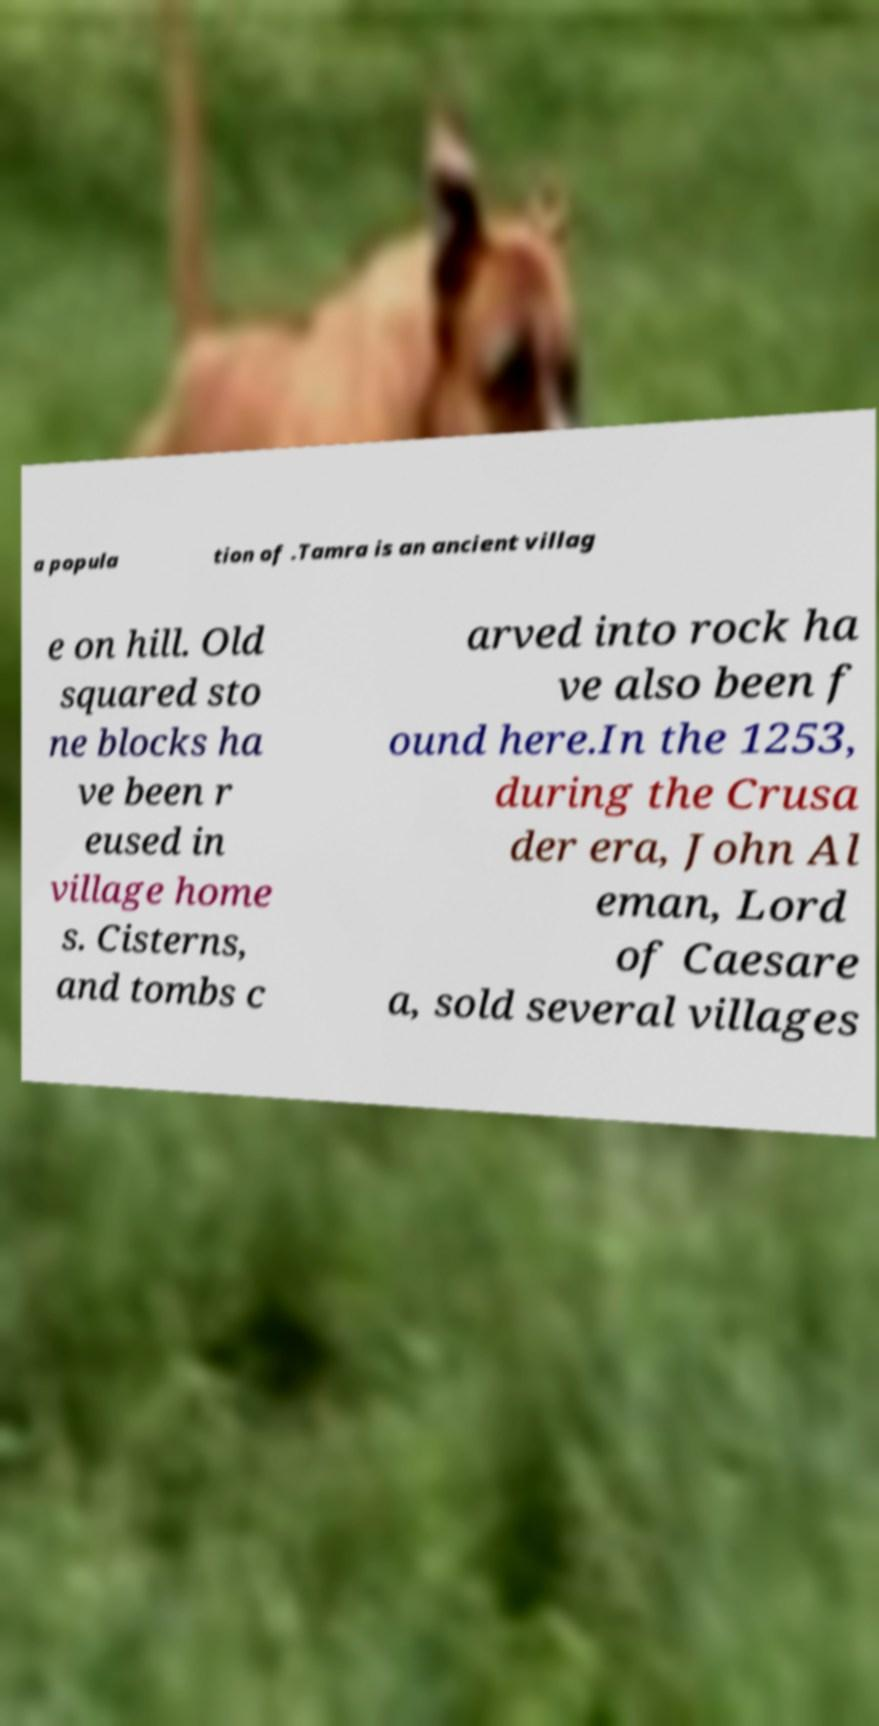Could you assist in decoding the text presented in this image and type it out clearly? a popula tion of .Tamra is an ancient villag e on hill. Old squared sto ne blocks ha ve been r eused in village home s. Cisterns, and tombs c arved into rock ha ve also been f ound here.In the 1253, during the Crusa der era, John Al eman, Lord of Caesare a, sold several villages 